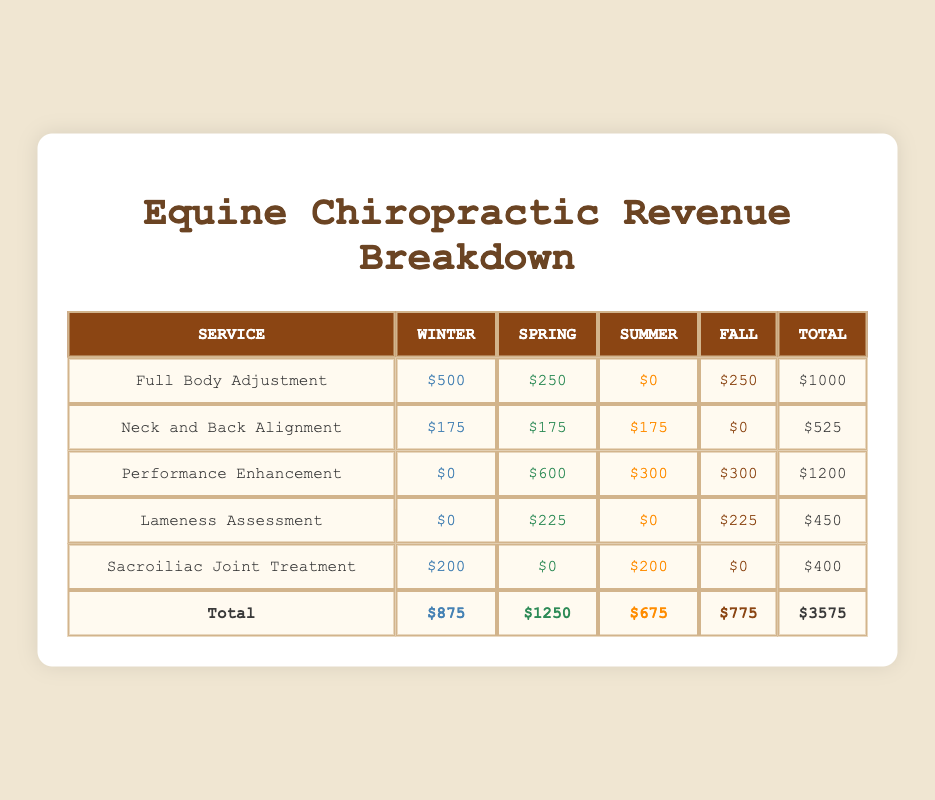What is the total revenue for the "Lameness Assessment" service? The total revenue for the "Lameness Assessment" service can be found by looking at the individual revenue amounts for each season. From the table: Winter = $0, Spring = $225, Summer = $0, Fall = $225. Adding these together gives us $0 + $225 + $0 + $225 = $450.
Answer: 450 Which service generated the highest revenue in the Spring season? To find the service with the highest revenue in Spring, we look at the Spring revenue column: Full Body Adjustment = $250, Neck and Back Alignment = $175, Performance Enhancement = $600, Lameness Assessment = $225, Sacroiliac Joint Treatment = $0. The highest amount is $600 from the Performance Enhancement service.
Answer: Performance Enhancement Is there any service that generated the same amount of revenue across all seasons? Checking the table, we see that Neck and Back Alignment generated $175 in Winter, Spring, and Summer, and $0 in Fall. No other service has the same revenue amount in all seasons. Therefore, the answer is no.
Answer: No What is the total revenue for all services in Winter? To calculate the total revenue for Winter, we sum the revenue amounts from the Winter column in the table: Full Body Adjustment = $500, Neck and Back Alignment = $175, Performance Enhancement = $0, Lameness Assessment = $0, Sacroiliac Joint Treatment = $200. Adding these yields $500 + $175 + $0 + $0 + $200 = $875.
Answer: 875 Which season generated the least total revenue, and what is that amount? First, we find the total revenue for each season: Winter = $875, Spring = $1250, Summer = $675, Fall = $775. The least amount occurs in Summer, which totals $675.
Answer: Summer, 675 What is the average revenue generated by the "Full Body Adjustment" service across all seasons? To find the average revenue of "Full Body Adjustment", we sum the revenue across all seasons: Winter = $500, Spring = $250, Summer = $0, Fall = $250, which gives us $500 + $250 + $0 + $250 = $1000. There are four seasons, so we divide $1000 by 4, resulting in an average of $250.
Answer: 250 How much more revenue did the "Performance Enhancement" service generate in Fall compared to Winter? The revenue for "Performance Enhancement" in Fall is $300, while in Winter it is $0. To find the difference, we subtract the Winter amount from the Fall amount: $300 - $0 = $300.
Answer: 300 Is there a season where no revenue was generated for "Sacroiliac Joint Treatment"? Looking at the revenue for "Sacroiliac Joint Treatment," we see Winter = $200, Spring = $0, Summer = $200, Fall = $0. Spring and Fall both had $0 revenue. Therefore, yes, there are seasons where no revenue was generated.
Answer: Yes 